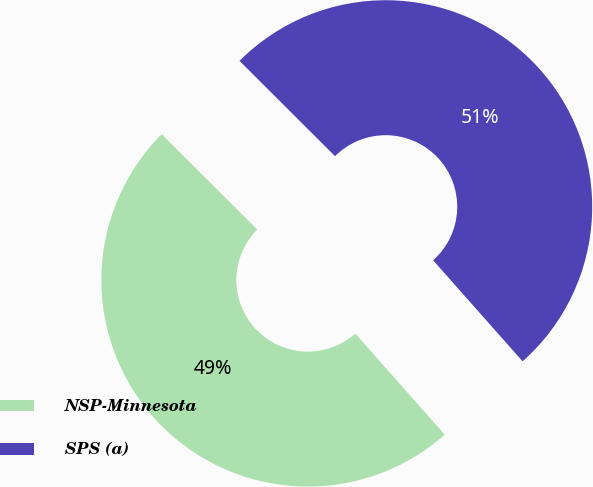Convert chart. <chart><loc_0><loc_0><loc_500><loc_500><pie_chart><fcel>NSP-Minnesota<fcel>SPS (a)<nl><fcel>49.02%<fcel>50.98%<nl></chart> 